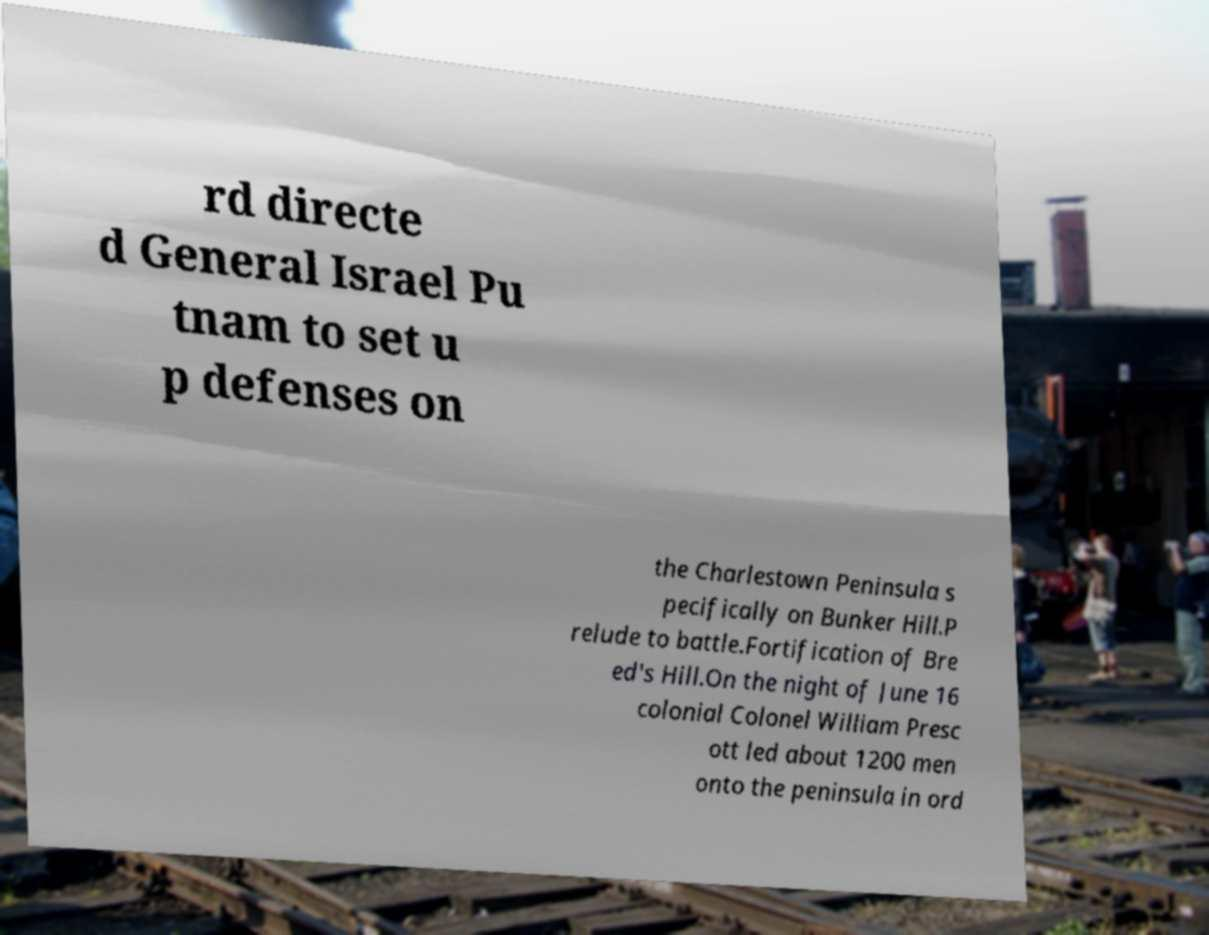Can you accurately transcribe the text from the provided image for me? rd directe d General Israel Pu tnam to set u p defenses on the Charlestown Peninsula s pecifically on Bunker Hill.P relude to battle.Fortification of Bre ed's Hill.On the night of June 16 colonial Colonel William Presc ott led about 1200 men onto the peninsula in ord 